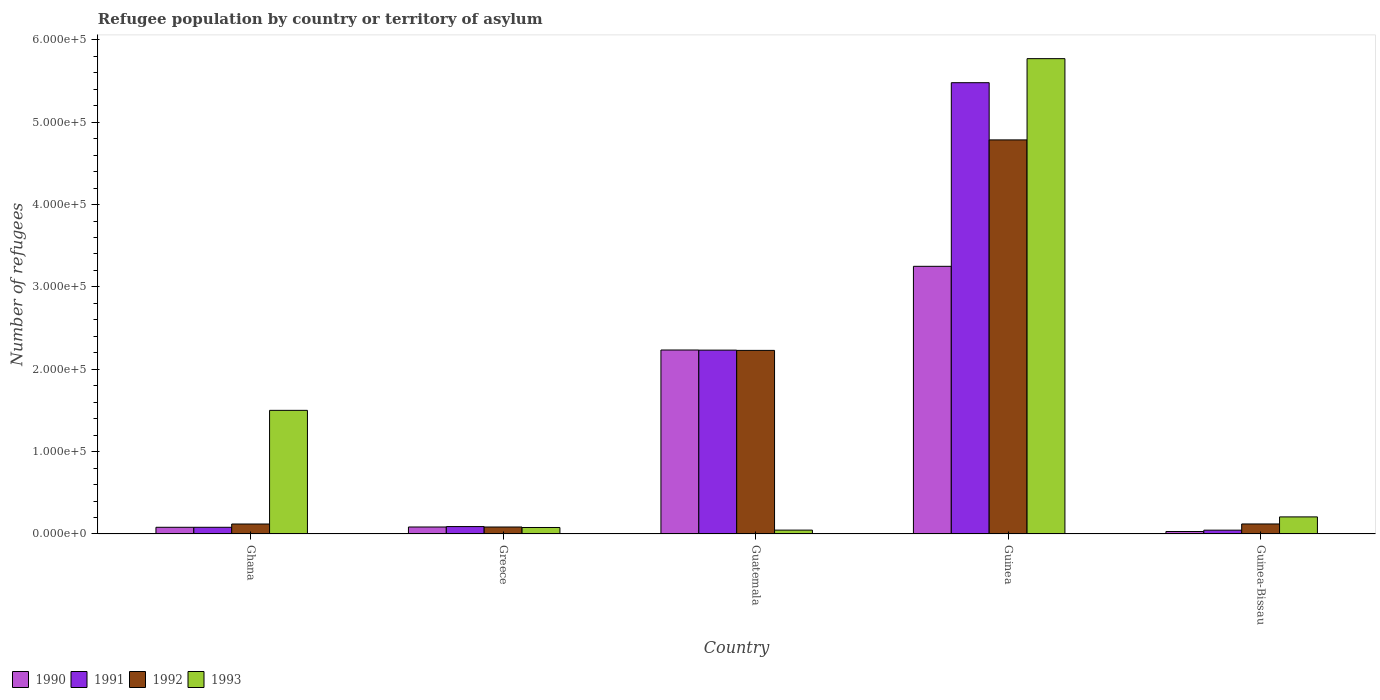How many different coloured bars are there?
Offer a terse response. 4. Are the number of bars per tick equal to the number of legend labels?
Your answer should be very brief. Yes. How many bars are there on the 3rd tick from the left?
Offer a terse response. 4. How many bars are there on the 1st tick from the right?
Your response must be concise. 4. What is the label of the 2nd group of bars from the left?
Your response must be concise. Greece. What is the number of refugees in 1991 in Guinea-Bissau?
Make the answer very short. 4631. Across all countries, what is the maximum number of refugees in 1993?
Your answer should be compact. 5.77e+05. Across all countries, what is the minimum number of refugees in 1990?
Provide a short and direct response. 3004. In which country was the number of refugees in 1993 maximum?
Your answer should be compact. Guinea. In which country was the number of refugees in 1993 minimum?
Ensure brevity in your answer.  Guatemala. What is the total number of refugees in 1993 in the graph?
Keep it short and to the point. 7.61e+05. What is the difference between the number of refugees in 1992 in Ghana and that in Guinea?
Provide a short and direct response. -4.66e+05. What is the difference between the number of refugees in 1993 in Guatemala and the number of refugees in 1990 in Ghana?
Ensure brevity in your answer.  -3434. What is the average number of refugees in 1993 per country?
Keep it short and to the point. 1.52e+05. What is the difference between the number of refugees of/in 1990 and number of refugees of/in 1993 in Greece?
Make the answer very short. 615. In how many countries, is the number of refugees in 1990 greater than 320000?
Offer a terse response. 1. What is the ratio of the number of refugees in 1992 in Ghana to that in Guatemala?
Give a very brief answer. 0.05. Is the difference between the number of refugees in 1990 in Guinea and Guinea-Bissau greater than the difference between the number of refugees in 1993 in Guinea and Guinea-Bissau?
Give a very brief answer. No. What is the difference between the highest and the second highest number of refugees in 1990?
Ensure brevity in your answer.  1.02e+05. What is the difference between the highest and the lowest number of refugees in 1991?
Provide a short and direct response. 5.43e+05. Is the sum of the number of refugees in 1991 in Greece and Guinea greater than the maximum number of refugees in 1990 across all countries?
Your answer should be very brief. Yes. Is it the case that in every country, the sum of the number of refugees in 1991 and number of refugees in 1990 is greater than the sum of number of refugees in 1992 and number of refugees in 1993?
Keep it short and to the point. No. What does the 3rd bar from the left in Guinea-Bissau represents?
Your answer should be very brief. 1992. What does the 2nd bar from the right in Guinea represents?
Offer a terse response. 1992. Are all the bars in the graph horizontal?
Your response must be concise. No. Does the graph contain any zero values?
Keep it short and to the point. No. Where does the legend appear in the graph?
Your response must be concise. Bottom left. How are the legend labels stacked?
Offer a very short reply. Horizontal. What is the title of the graph?
Provide a succinct answer. Refugee population by country or territory of asylum. Does "1989" appear as one of the legend labels in the graph?
Give a very brief answer. No. What is the label or title of the Y-axis?
Offer a very short reply. Number of refugees. What is the Number of refugees of 1990 in Ghana?
Offer a very short reply. 8123. What is the Number of refugees of 1991 in Ghana?
Give a very brief answer. 8128. What is the Number of refugees of 1992 in Ghana?
Ensure brevity in your answer.  1.21e+04. What is the Number of refugees in 1993 in Ghana?
Ensure brevity in your answer.  1.50e+05. What is the Number of refugees of 1990 in Greece?
Ensure brevity in your answer.  8488. What is the Number of refugees of 1991 in Greece?
Keep it short and to the point. 8989. What is the Number of refugees in 1992 in Greece?
Keep it short and to the point. 8456. What is the Number of refugees in 1993 in Greece?
Your response must be concise. 7873. What is the Number of refugees of 1990 in Guatemala?
Provide a succinct answer. 2.23e+05. What is the Number of refugees in 1991 in Guatemala?
Give a very brief answer. 2.23e+05. What is the Number of refugees of 1992 in Guatemala?
Give a very brief answer. 2.23e+05. What is the Number of refugees in 1993 in Guatemala?
Your response must be concise. 4689. What is the Number of refugees in 1990 in Guinea?
Provide a short and direct response. 3.25e+05. What is the Number of refugees in 1991 in Guinea?
Provide a short and direct response. 5.48e+05. What is the Number of refugees in 1992 in Guinea?
Your answer should be compact. 4.78e+05. What is the Number of refugees of 1993 in Guinea?
Your answer should be very brief. 5.77e+05. What is the Number of refugees in 1990 in Guinea-Bissau?
Your answer should be compact. 3004. What is the Number of refugees in 1991 in Guinea-Bissau?
Offer a terse response. 4631. What is the Number of refugees of 1992 in Guinea-Bissau?
Your response must be concise. 1.22e+04. What is the Number of refugees in 1993 in Guinea-Bissau?
Provide a succinct answer. 2.07e+04. Across all countries, what is the maximum Number of refugees in 1990?
Keep it short and to the point. 3.25e+05. Across all countries, what is the maximum Number of refugees in 1991?
Give a very brief answer. 5.48e+05. Across all countries, what is the maximum Number of refugees of 1992?
Give a very brief answer. 4.78e+05. Across all countries, what is the maximum Number of refugees in 1993?
Your answer should be very brief. 5.77e+05. Across all countries, what is the minimum Number of refugees of 1990?
Offer a terse response. 3004. Across all countries, what is the minimum Number of refugees in 1991?
Make the answer very short. 4631. Across all countries, what is the minimum Number of refugees of 1992?
Offer a very short reply. 8456. Across all countries, what is the minimum Number of refugees in 1993?
Keep it short and to the point. 4689. What is the total Number of refugees of 1990 in the graph?
Provide a succinct answer. 5.68e+05. What is the total Number of refugees in 1991 in the graph?
Provide a succinct answer. 7.93e+05. What is the total Number of refugees of 1992 in the graph?
Make the answer very short. 7.34e+05. What is the total Number of refugees in 1993 in the graph?
Make the answer very short. 7.61e+05. What is the difference between the Number of refugees of 1990 in Ghana and that in Greece?
Offer a terse response. -365. What is the difference between the Number of refugees in 1991 in Ghana and that in Greece?
Offer a terse response. -861. What is the difference between the Number of refugees of 1992 in Ghana and that in Greece?
Ensure brevity in your answer.  3658. What is the difference between the Number of refugees in 1993 in Ghana and that in Greece?
Offer a terse response. 1.42e+05. What is the difference between the Number of refugees of 1990 in Ghana and that in Guatemala?
Provide a succinct answer. -2.15e+05. What is the difference between the Number of refugees of 1991 in Ghana and that in Guatemala?
Offer a very short reply. -2.15e+05. What is the difference between the Number of refugees in 1992 in Ghana and that in Guatemala?
Offer a terse response. -2.11e+05. What is the difference between the Number of refugees of 1993 in Ghana and that in Guatemala?
Your answer should be compact. 1.45e+05. What is the difference between the Number of refugees of 1990 in Ghana and that in Guinea?
Offer a very short reply. -3.17e+05. What is the difference between the Number of refugees of 1991 in Ghana and that in Guinea?
Your answer should be compact. -5.40e+05. What is the difference between the Number of refugees in 1992 in Ghana and that in Guinea?
Your response must be concise. -4.66e+05. What is the difference between the Number of refugees in 1993 in Ghana and that in Guinea?
Your answer should be compact. -4.27e+05. What is the difference between the Number of refugees in 1990 in Ghana and that in Guinea-Bissau?
Your response must be concise. 5119. What is the difference between the Number of refugees of 1991 in Ghana and that in Guinea-Bissau?
Provide a succinct answer. 3497. What is the difference between the Number of refugees in 1992 in Ghana and that in Guinea-Bissau?
Provide a succinct answer. -49. What is the difference between the Number of refugees of 1993 in Ghana and that in Guinea-Bissau?
Your response must be concise. 1.29e+05. What is the difference between the Number of refugees in 1990 in Greece and that in Guatemala?
Offer a very short reply. -2.15e+05. What is the difference between the Number of refugees of 1991 in Greece and that in Guatemala?
Make the answer very short. -2.14e+05. What is the difference between the Number of refugees in 1992 in Greece and that in Guatemala?
Give a very brief answer. -2.14e+05. What is the difference between the Number of refugees in 1993 in Greece and that in Guatemala?
Your response must be concise. 3184. What is the difference between the Number of refugees of 1990 in Greece and that in Guinea?
Your answer should be very brief. -3.17e+05. What is the difference between the Number of refugees of 1991 in Greece and that in Guinea?
Make the answer very short. -5.39e+05. What is the difference between the Number of refugees of 1992 in Greece and that in Guinea?
Your answer should be compact. -4.70e+05. What is the difference between the Number of refugees in 1993 in Greece and that in Guinea?
Ensure brevity in your answer.  -5.69e+05. What is the difference between the Number of refugees in 1990 in Greece and that in Guinea-Bissau?
Provide a short and direct response. 5484. What is the difference between the Number of refugees of 1991 in Greece and that in Guinea-Bissau?
Offer a very short reply. 4358. What is the difference between the Number of refugees in 1992 in Greece and that in Guinea-Bissau?
Your response must be concise. -3707. What is the difference between the Number of refugees of 1993 in Greece and that in Guinea-Bissau?
Your answer should be compact. -1.29e+04. What is the difference between the Number of refugees in 1990 in Guatemala and that in Guinea?
Provide a short and direct response. -1.02e+05. What is the difference between the Number of refugees in 1991 in Guatemala and that in Guinea?
Make the answer very short. -3.25e+05. What is the difference between the Number of refugees in 1992 in Guatemala and that in Guinea?
Your answer should be very brief. -2.56e+05. What is the difference between the Number of refugees of 1993 in Guatemala and that in Guinea?
Your answer should be compact. -5.72e+05. What is the difference between the Number of refugees in 1990 in Guatemala and that in Guinea-Bissau?
Your response must be concise. 2.20e+05. What is the difference between the Number of refugees in 1991 in Guatemala and that in Guinea-Bissau?
Offer a terse response. 2.19e+05. What is the difference between the Number of refugees of 1992 in Guatemala and that in Guinea-Bissau?
Offer a terse response. 2.11e+05. What is the difference between the Number of refugees of 1993 in Guatemala and that in Guinea-Bissau?
Your answer should be very brief. -1.60e+04. What is the difference between the Number of refugees in 1990 in Guinea and that in Guinea-Bissau?
Make the answer very short. 3.22e+05. What is the difference between the Number of refugees in 1991 in Guinea and that in Guinea-Bissau?
Give a very brief answer. 5.43e+05. What is the difference between the Number of refugees in 1992 in Guinea and that in Guinea-Bissau?
Provide a short and direct response. 4.66e+05. What is the difference between the Number of refugees of 1993 in Guinea and that in Guinea-Bissau?
Keep it short and to the point. 5.56e+05. What is the difference between the Number of refugees in 1990 in Ghana and the Number of refugees in 1991 in Greece?
Give a very brief answer. -866. What is the difference between the Number of refugees of 1990 in Ghana and the Number of refugees of 1992 in Greece?
Keep it short and to the point. -333. What is the difference between the Number of refugees of 1990 in Ghana and the Number of refugees of 1993 in Greece?
Give a very brief answer. 250. What is the difference between the Number of refugees in 1991 in Ghana and the Number of refugees in 1992 in Greece?
Make the answer very short. -328. What is the difference between the Number of refugees of 1991 in Ghana and the Number of refugees of 1993 in Greece?
Provide a succinct answer. 255. What is the difference between the Number of refugees in 1992 in Ghana and the Number of refugees in 1993 in Greece?
Provide a succinct answer. 4241. What is the difference between the Number of refugees in 1990 in Ghana and the Number of refugees in 1991 in Guatemala?
Provide a succinct answer. -2.15e+05. What is the difference between the Number of refugees in 1990 in Ghana and the Number of refugees in 1992 in Guatemala?
Your response must be concise. -2.15e+05. What is the difference between the Number of refugees in 1990 in Ghana and the Number of refugees in 1993 in Guatemala?
Offer a very short reply. 3434. What is the difference between the Number of refugees of 1991 in Ghana and the Number of refugees of 1992 in Guatemala?
Give a very brief answer. -2.15e+05. What is the difference between the Number of refugees of 1991 in Ghana and the Number of refugees of 1993 in Guatemala?
Provide a succinct answer. 3439. What is the difference between the Number of refugees of 1992 in Ghana and the Number of refugees of 1993 in Guatemala?
Provide a short and direct response. 7425. What is the difference between the Number of refugees in 1990 in Ghana and the Number of refugees in 1991 in Guinea?
Your response must be concise. -5.40e+05. What is the difference between the Number of refugees in 1990 in Ghana and the Number of refugees in 1992 in Guinea?
Give a very brief answer. -4.70e+05. What is the difference between the Number of refugees in 1990 in Ghana and the Number of refugees in 1993 in Guinea?
Your answer should be compact. -5.69e+05. What is the difference between the Number of refugees of 1991 in Ghana and the Number of refugees of 1992 in Guinea?
Your answer should be very brief. -4.70e+05. What is the difference between the Number of refugees in 1991 in Ghana and the Number of refugees in 1993 in Guinea?
Your answer should be compact. -5.69e+05. What is the difference between the Number of refugees in 1992 in Ghana and the Number of refugees in 1993 in Guinea?
Provide a short and direct response. -5.65e+05. What is the difference between the Number of refugees of 1990 in Ghana and the Number of refugees of 1991 in Guinea-Bissau?
Your answer should be compact. 3492. What is the difference between the Number of refugees in 1990 in Ghana and the Number of refugees in 1992 in Guinea-Bissau?
Provide a succinct answer. -4040. What is the difference between the Number of refugees of 1990 in Ghana and the Number of refugees of 1993 in Guinea-Bissau?
Ensure brevity in your answer.  -1.26e+04. What is the difference between the Number of refugees in 1991 in Ghana and the Number of refugees in 1992 in Guinea-Bissau?
Offer a terse response. -4035. What is the difference between the Number of refugees of 1991 in Ghana and the Number of refugees of 1993 in Guinea-Bissau?
Offer a very short reply. -1.26e+04. What is the difference between the Number of refugees in 1992 in Ghana and the Number of refugees in 1993 in Guinea-Bissau?
Offer a terse response. -8621. What is the difference between the Number of refugees of 1990 in Greece and the Number of refugees of 1991 in Guatemala?
Give a very brief answer. -2.15e+05. What is the difference between the Number of refugees in 1990 in Greece and the Number of refugees in 1992 in Guatemala?
Provide a short and direct response. -2.14e+05. What is the difference between the Number of refugees of 1990 in Greece and the Number of refugees of 1993 in Guatemala?
Ensure brevity in your answer.  3799. What is the difference between the Number of refugees of 1991 in Greece and the Number of refugees of 1992 in Guatemala?
Make the answer very short. -2.14e+05. What is the difference between the Number of refugees in 1991 in Greece and the Number of refugees in 1993 in Guatemala?
Make the answer very short. 4300. What is the difference between the Number of refugees in 1992 in Greece and the Number of refugees in 1993 in Guatemala?
Keep it short and to the point. 3767. What is the difference between the Number of refugees in 1990 in Greece and the Number of refugees in 1991 in Guinea?
Provide a succinct answer. -5.39e+05. What is the difference between the Number of refugees in 1990 in Greece and the Number of refugees in 1992 in Guinea?
Your response must be concise. -4.70e+05. What is the difference between the Number of refugees in 1990 in Greece and the Number of refugees in 1993 in Guinea?
Provide a succinct answer. -5.69e+05. What is the difference between the Number of refugees of 1991 in Greece and the Number of refugees of 1992 in Guinea?
Your answer should be very brief. -4.70e+05. What is the difference between the Number of refugees in 1991 in Greece and the Number of refugees in 1993 in Guinea?
Provide a short and direct response. -5.68e+05. What is the difference between the Number of refugees of 1992 in Greece and the Number of refugees of 1993 in Guinea?
Offer a very short reply. -5.69e+05. What is the difference between the Number of refugees of 1990 in Greece and the Number of refugees of 1991 in Guinea-Bissau?
Provide a succinct answer. 3857. What is the difference between the Number of refugees of 1990 in Greece and the Number of refugees of 1992 in Guinea-Bissau?
Make the answer very short. -3675. What is the difference between the Number of refugees in 1990 in Greece and the Number of refugees in 1993 in Guinea-Bissau?
Your response must be concise. -1.22e+04. What is the difference between the Number of refugees in 1991 in Greece and the Number of refugees in 1992 in Guinea-Bissau?
Give a very brief answer. -3174. What is the difference between the Number of refugees of 1991 in Greece and the Number of refugees of 1993 in Guinea-Bissau?
Make the answer very short. -1.17e+04. What is the difference between the Number of refugees in 1992 in Greece and the Number of refugees in 1993 in Guinea-Bissau?
Make the answer very short. -1.23e+04. What is the difference between the Number of refugees in 1990 in Guatemala and the Number of refugees in 1991 in Guinea?
Offer a terse response. -3.25e+05. What is the difference between the Number of refugees of 1990 in Guatemala and the Number of refugees of 1992 in Guinea?
Make the answer very short. -2.55e+05. What is the difference between the Number of refugees in 1990 in Guatemala and the Number of refugees in 1993 in Guinea?
Provide a succinct answer. -3.54e+05. What is the difference between the Number of refugees in 1991 in Guatemala and the Number of refugees in 1992 in Guinea?
Provide a succinct answer. -2.55e+05. What is the difference between the Number of refugees in 1991 in Guatemala and the Number of refugees in 1993 in Guinea?
Offer a terse response. -3.54e+05. What is the difference between the Number of refugees of 1992 in Guatemala and the Number of refugees of 1993 in Guinea?
Your answer should be very brief. -3.54e+05. What is the difference between the Number of refugees of 1990 in Guatemala and the Number of refugees of 1991 in Guinea-Bissau?
Your answer should be very brief. 2.19e+05. What is the difference between the Number of refugees of 1990 in Guatemala and the Number of refugees of 1992 in Guinea-Bissau?
Give a very brief answer. 2.11e+05. What is the difference between the Number of refugees of 1990 in Guatemala and the Number of refugees of 1993 in Guinea-Bissau?
Give a very brief answer. 2.03e+05. What is the difference between the Number of refugees in 1991 in Guatemala and the Number of refugees in 1992 in Guinea-Bissau?
Keep it short and to the point. 2.11e+05. What is the difference between the Number of refugees in 1991 in Guatemala and the Number of refugees in 1993 in Guinea-Bissau?
Offer a very short reply. 2.03e+05. What is the difference between the Number of refugees of 1992 in Guatemala and the Number of refugees of 1993 in Guinea-Bissau?
Keep it short and to the point. 2.02e+05. What is the difference between the Number of refugees of 1990 in Guinea and the Number of refugees of 1991 in Guinea-Bissau?
Provide a short and direct response. 3.20e+05. What is the difference between the Number of refugees in 1990 in Guinea and the Number of refugees in 1992 in Guinea-Bissau?
Make the answer very short. 3.13e+05. What is the difference between the Number of refugees in 1990 in Guinea and the Number of refugees in 1993 in Guinea-Bissau?
Your answer should be very brief. 3.04e+05. What is the difference between the Number of refugees in 1991 in Guinea and the Number of refugees in 1992 in Guinea-Bissau?
Provide a succinct answer. 5.36e+05. What is the difference between the Number of refugees in 1991 in Guinea and the Number of refugees in 1993 in Guinea-Bissau?
Your answer should be very brief. 5.27e+05. What is the difference between the Number of refugees in 1992 in Guinea and the Number of refugees in 1993 in Guinea-Bissau?
Give a very brief answer. 4.58e+05. What is the average Number of refugees of 1990 per country?
Provide a short and direct response. 1.14e+05. What is the average Number of refugees in 1991 per country?
Offer a terse response. 1.59e+05. What is the average Number of refugees of 1992 per country?
Provide a succinct answer. 1.47e+05. What is the average Number of refugees in 1993 per country?
Keep it short and to the point. 1.52e+05. What is the difference between the Number of refugees of 1990 and Number of refugees of 1992 in Ghana?
Make the answer very short. -3991. What is the difference between the Number of refugees in 1990 and Number of refugees in 1993 in Ghana?
Provide a succinct answer. -1.42e+05. What is the difference between the Number of refugees in 1991 and Number of refugees in 1992 in Ghana?
Provide a succinct answer. -3986. What is the difference between the Number of refugees of 1991 and Number of refugees of 1993 in Ghana?
Your answer should be compact. -1.42e+05. What is the difference between the Number of refugees in 1992 and Number of refugees in 1993 in Ghana?
Provide a succinct answer. -1.38e+05. What is the difference between the Number of refugees of 1990 and Number of refugees of 1991 in Greece?
Your answer should be compact. -501. What is the difference between the Number of refugees of 1990 and Number of refugees of 1992 in Greece?
Offer a terse response. 32. What is the difference between the Number of refugees of 1990 and Number of refugees of 1993 in Greece?
Offer a terse response. 615. What is the difference between the Number of refugees of 1991 and Number of refugees of 1992 in Greece?
Your answer should be compact. 533. What is the difference between the Number of refugees of 1991 and Number of refugees of 1993 in Greece?
Give a very brief answer. 1116. What is the difference between the Number of refugees in 1992 and Number of refugees in 1993 in Greece?
Offer a terse response. 583. What is the difference between the Number of refugees in 1990 and Number of refugees in 1991 in Guatemala?
Your answer should be compact. 141. What is the difference between the Number of refugees of 1990 and Number of refugees of 1992 in Guatemala?
Give a very brief answer. 448. What is the difference between the Number of refugees of 1990 and Number of refugees of 1993 in Guatemala?
Keep it short and to the point. 2.19e+05. What is the difference between the Number of refugees of 1991 and Number of refugees of 1992 in Guatemala?
Keep it short and to the point. 307. What is the difference between the Number of refugees of 1991 and Number of refugees of 1993 in Guatemala?
Provide a short and direct response. 2.19e+05. What is the difference between the Number of refugees in 1992 and Number of refugees in 1993 in Guatemala?
Offer a terse response. 2.18e+05. What is the difference between the Number of refugees of 1990 and Number of refugees of 1991 in Guinea?
Your answer should be compact. -2.23e+05. What is the difference between the Number of refugees of 1990 and Number of refugees of 1992 in Guinea?
Keep it short and to the point. -1.53e+05. What is the difference between the Number of refugees of 1990 and Number of refugees of 1993 in Guinea?
Make the answer very short. -2.52e+05. What is the difference between the Number of refugees of 1991 and Number of refugees of 1992 in Guinea?
Your answer should be compact. 6.95e+04. What is the difference between the Number of refugees of 1991 and Number of refugees of 1993 in Guinea?
Offer a very short reply. -2.92e+04. What is the difference between the Number of refugees of 1992 and Number of refugees of 1993 in Guinea?
Your answer should be very brief. -9.87e+04. What is the difference between the Number of refugees of 1990 and Number of refugees of 1991 in Guinea-Bissau?
Ensure brevity in your answer.  -1627. What is the difference between the Number of refugees of 1990 and Number of refugees of 1992 in Guinea-Bissau?
Your response must be concise. -9159. What is the difference between the Number of refugees of 1990 and Number of refugees of 1993 in Guinea-Bissau?
Make the answer very short. -1.77e+04. What is the difference between the Number of refugees of 1991 and Number of refugees of 1992 in Guinea-Bissau?
Provide a short and direct response. -7532. What is the difference between the Number of refugees of 1991 and Number of refugees of 1993 in Guinea-Bissau?
Your answer should be very brief. -1.61e+04. What is the difference between the Number of refugees of 1992 and Number of refugees of 1993 in Guinea-Bissau?
Make the answer very short. -8572. What is the ratio of the Number of refugees of 1991 in Ghana to that in Greece?
Make the answer very short. 0.9. What is the ratio of the Number of refugees in 1992 in Ghana to that in Greece?
Ensure brevity in your answer.  1.43. What is the ratio of the Number of refugees of 1993 in Ghana to that in Greece?
Your response must be concise. 19.07. What is the ratio of the Number of refugees of 1990 in Ghana to that in Guatemala?
Provide a short and direct response. 0.04. What is the ratio of the Number of refugees of 1991 in Ghana to that in Guatemala?
Your response must be concise. 0.04. What is the ratio of the Number of refugees of 1992 in Ghana to that in Guatemala?
Offer a very short reply. 0.05. What is the ratio of the Number of refugees in 1993 in Ghana to that in Guatemala?
Ensure brevity in your answer.  32.01. What is the ratio of the Number of refugees of 1990 in Ghana to that in Guinea?
Your response must be concise. 0.03. What is the ratio of the Number of refugees of 1991 in Ghana to that in Guinea?
Your response must be concise. 0.01. What is the ratio of the Number of refugees in 1992 in Ghana to that in Guinea?
Provide a succinct answer. 0.03. What is the ratio of the Number of refugees of 1993 in Ghana to that in Guinea?
Keep it short and to the point. 0.26. What is the ratio of the Number of refugees in 1990 in Ghana to that in Guinea-Bissau?
Your answer should be very brief. 2.7. What is the ratio of the Number of refugees in 1991 in Ghana to that in Guinea-Bissau?
Your answer should be very brief. 1.76. What is the ratio of the Number of refugees of 1993 in Ghana to that in Guinea-Bissau?
Provide a short and direct response. 7.24. What is the ratio of the Number of refugees in 1990 in Greece to that in Guatemala?
Your response must be concise. 0.04. What is the ratio of the Number of refugees in 1991 in Greece to that in Guatemala?
Keep it short and to the point. 0.04. What is the ratio of the Number of refugees of 1992 in Greece to that in Guatemala?
Provide a succinct answer. 0.04. What is the ratio of the Number of refugees in 1993 in Greece to that in Guatemala?
Provide a short and direct response. 1.68. What is the ratio of the Number of refugees of 1990 in Greece to that in Guinea?
Ensure brevity in your answer.  0.03. What is the ratio of the Number of refugees in 1991 in Greece to that in Guinea?
Keep it short and to the point. 0.02. What is the ratio of the Number of refugees in 1992 in Greece to that in Guinea?
Keep it short and to the point. 0.02. What is the ratio of the Number of refugees of 1993 in Greece to that in Guinea?
Provide a short and direct response. 0.01. What is the ratio of the Number of refugees in 1990 in Greece to that in Guinea-Bissau?
Offer a terse response. 2.83. What is the ratio of the Number of refugees of 1991 in Greece to that in Guinea-Bissau?
Give a very brief answer. 1.94. What is the ratio of the Number of refugees in 1992 in Greece to that in Guinea-Bissau?
Ensure brevity in your answer.  0.7. What is the ratio of the Number of refugees in 1993 in Greece to that in Guinea-Bissau?
Your answer should be very brief. 0.38. What is the ratio of the Number of refugees of 1990 in Guatemala to that in Guinea?
Provide a short and direct response. 0.69. What is the ratio of the Number of refugees of 1991 in Guatemala to that in Guinea?
Your response must be concise. 0.41. What is the ratio of the Number of refugees in 1992 in Guatemala to that in Guinea?
Your answer should be compact. 0.47. What is the ratio of the Number of refugees of 1993 in Guatemala to that in Guinea?
Your response must be concise. 0.01. What is the ratio of the Number of refugees of 1990 in Guatemala to that in Guinea-Bissau?
Give a very brief answer. 74.36. What is the ratio of the Number of refugees in 1991 in Guatemala to that in Guinea-Bissau?
Give a very brief answer. 48.2. What is the ratio of the Number of refugees of 1992 in Guatemala to that in Guinea-Bissau?
Provide a short and direct response. 18.33. What is the ratio of the Number of refugees of 1993 in Guatemala to that in Guinea-Bissau?
Offer a very short reply. 0.23. What is the ratio of the Number of refugees of 1990 in Guinea to that in Guinea-Bissau?
Ensure brevity in your answer.  108.19. What is the ratio of the Number of refugees in 1991 in Guinea to that in Guinea-Bissau?
Offer a very short reply. 118.32. What is the ratio of the Number of refugees of 1992 in Guinea to that in Guinea-Bissau?
Offer a very short reply. 39.34. What is the ratio of the Number of refugees in 1993 in Guinea to that in Guinea-Bissau?
Your answer should be compact. 27.84. What is the difference between the highest and the second highest Number of refugees in 1990?
Offer a very short reply. 1.02e+05. What is the difference between the highest and the second highest Number of refugees in 1991?
Provide a short and direct response. 3.25e+05. What is the difference between the highest and the second highest Number of refugees in 1992?
Keep it short and to the point. 2.56e+05. What is the difference between the highest and the second highest Number of refugees of 1993?
Offer a terse response. 4.27e+05. What is the difference between the highest and the lowest Number of refugees of 1990?
Your answer should be compact. 3.22e+05. What is the difference between the highest and the lowest Number of refugees of 1991?
Your response must be concise. 5.43e+05. What is the difference between the highest and the lowest Number of refugees of 1992?
Offer a terse response. 4.70e+05. What is the difference between the highest and the lowest Number of refugees in 1993?
Keep it short and to the point. 5.72e+05. 